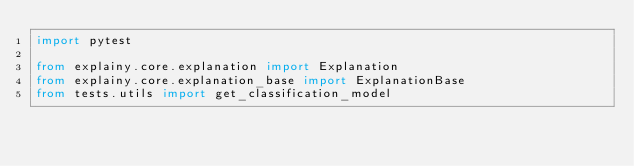<code> <loc_0><loc_0><loc_500><loc_500><_Python_>import pytest

from explainy.core.explanation import Explanation
from explainy.core.explanation_base import ExplanationBase
from tests.utils import get_classification_model

</code> 